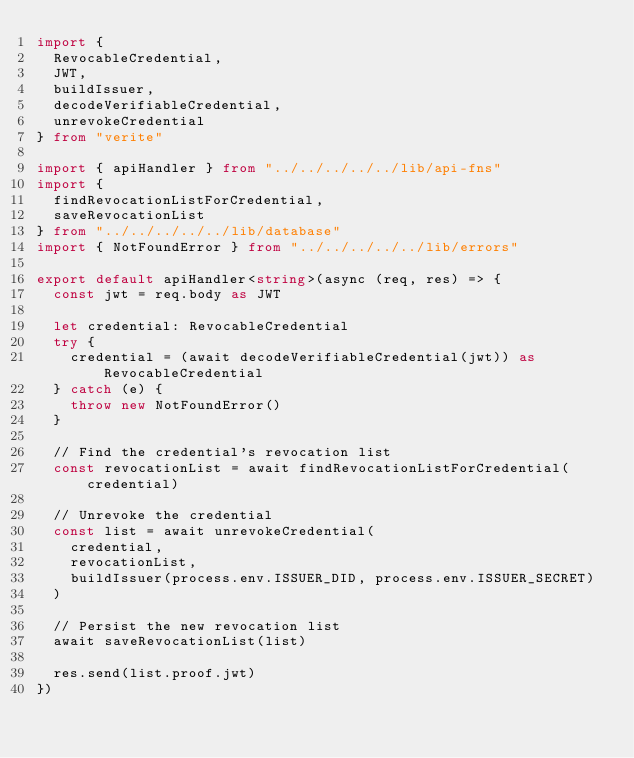Convert code to text. <code><loc_0><loc_0><loc_500><loc_500><_TypeScript_>import {
  RevocableCredential,
  JWT,
  buildIssuer,
  decodeVerifiableCredential,
  unrevokeCredential
} from "verite"

import { apiHandler } from "../../../../../lib/api-fns"
import {
  findRevocationListForCredential,
  saveRevocationList
} from "../../../../../lib/database"
import { NotFoundError } from "../../../../../lib/errors"

export default apiHandler<string>(async (req, res) => {
  const jwt = req.body as JWT

  let credential: RevocableCredential
  try {
    credential = (await decodeVerifiableCredential(jwt)) as RevocableCredential
  } catch (e) {
    throw new NotFoundError()
  }

  // Find the credential's revocation list
  const revocationList = await findRevocationListForCredential(credential)

  // Unrevoke the credential
  const list = await unrevokeCredential(
    credential,
    revocationList,
    buildIssuer(process.env.ISSUER_DID, process.env.ISSUER_SECRET)
  )

  // Persist the new revocation list
  await saveRevocationList(list)

  res.send(list.proof.jwt)
})
</code> 